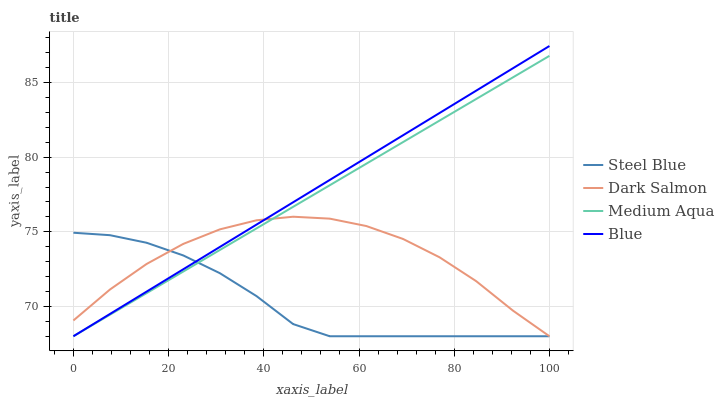Does Medium Aqua have the minimum area under the curve?
Answer yes or no. No. Does Medium Aqua have the maximum area under the curve?
Answer yes or no. No. Is Medium Aqua the smoothest?
Answer yes or no. No. Is Medium Aqua the roughest?
Answer yes or no. No. Does Medium Aqua have the highest value?
Answer yes or no. No. 